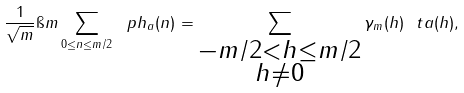<formula> <loc_0><loc_0><loc_500><loc_500>\frac { 1 } { \sqrt { m } } \i m \sum _ { 0 \leq n \leq m / 2 } \ p h _ { a } ( n ) = \sum _ { \substack { - m / 2 < h \leq m / 2 \\ h \neq 0 } } \gamma _ { m } ( h ) \ t a ( h ) ,</formula> 